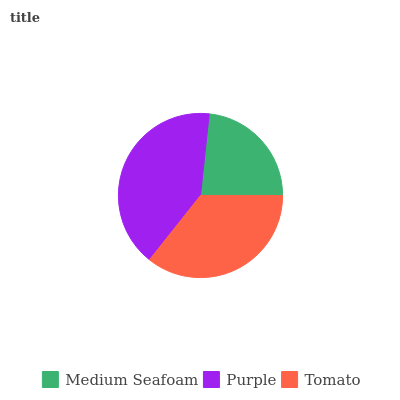Is Medium Seafoam the minimum?
Answer yes or no. Yes. Is Purple the maximum?
Answer yes or no. Yes. Is Tomato the minimum?
Answer yes or no. No. Is Tomato the maximum?
Answer yes or no. No. Is Purple greater than Tomato?
Answer yes or no. Yes. Is Tomato less than Purple?
Answer yes or no. Yes. Is Tomato greater than Purple?
Answer yes or no. No. Is Purple less than Tomato?
Answer yes or no. No. Is Tomato the high median?
Answer yes or no. Yes. Is Tomato the low median?
Answer yes or no. Yes. Is Medium Seafoam the high median?
Answer yes or no. No. Is Medium Seafoam the low median?
Answer yes or no. No. 